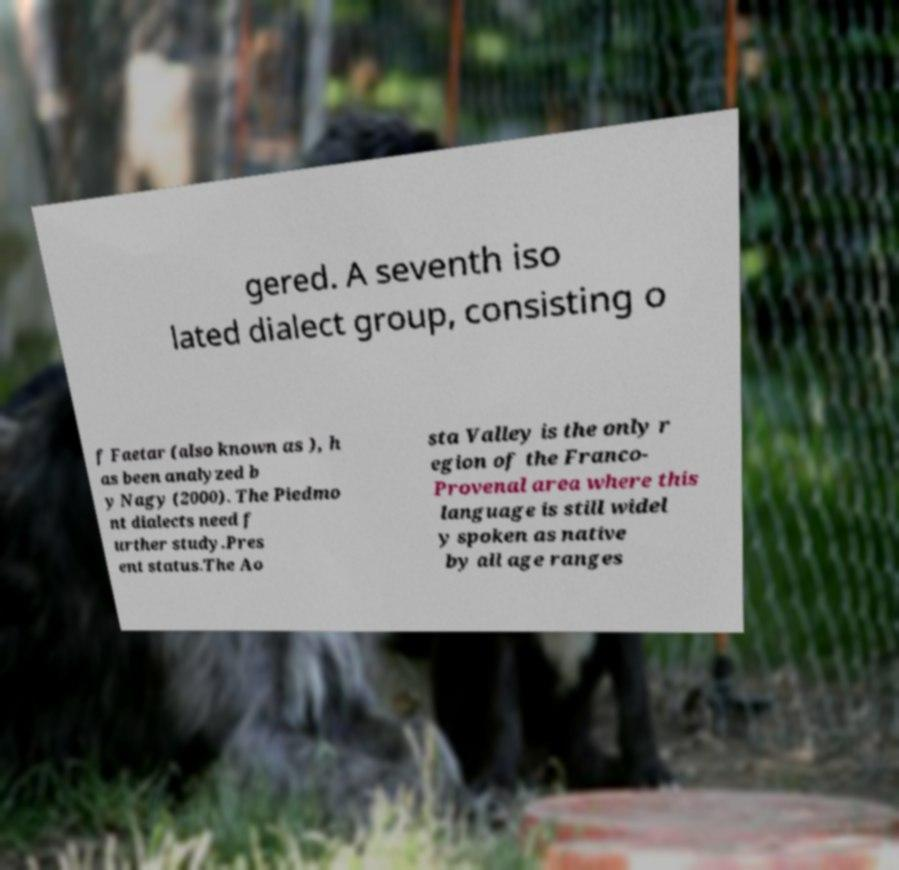Please read and relay the text visible in this image. What does it say? gered. A seventh iso lated dialect group, consisting o f Faetar (also known as ), h as been analyzed b y Nagy (2000). The Piedmo nt dialects need f urther study.Pres ent status.The Ao sta Valley is the only r egion of the Franco- Provenal area where this language is still widel y spoken as native by all age ranges 